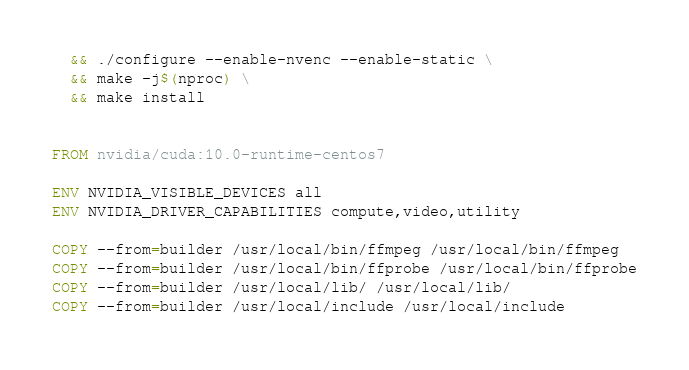<code> <loc_0><loc_0><loc_500><loc_500><_Dockerfile_>  && ./configure --enable-nvenc --enable-static \
  && make -j$(nproc) \
  && make install


FROM nvidia/cuda:10.0-runtime-centos7

ENV NVIDIA_VISIBLE_DEVICES all
ENV NVIDIA_DRIVER_CAPABILITIES compute,video,utility

COPY --from=builder /usr/local/bin/ffmpeg /usr/local/bin/ffmpeg
COPY --from=builder /usr/local/bin/ffprobe /usr/local/bin/ffprobe
COPY --from=builder /usr/local/lib/ /usr/local/lib/
COPY --from=builder /usr/local/include /usr/local/include
</code> 